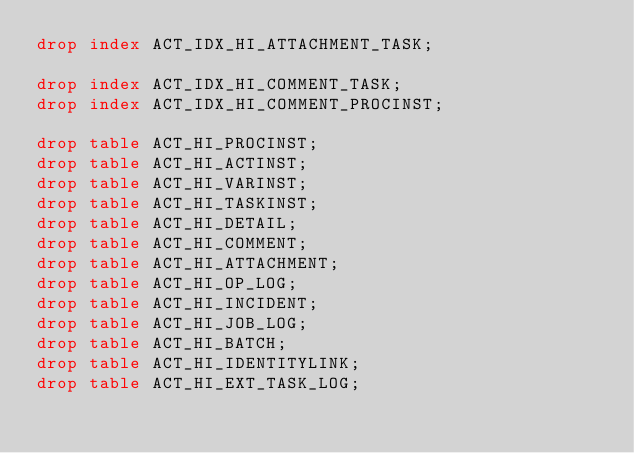<code> <loc_0><loc_0><loc_500><loc_500><_SQL_>drop index ACT_IDX_HI_ATTACHMENT_TASK;

drop index ACT_IDX_HI_COMMENT_TASK;
drop index ACT_IDX_HI_COMMENT_PROCINST;

drop table ACT_HI_PROCINST;
drop table ACT_HI_ACTINST;
drop table ACT_HI_VARINST;
drop table ACT_HI_TASKINST;
drop table ACT_HI_DETAIL;
drop table ACT_HI_COMMENT;
drop table ACT_HI_ATTACHMENT;
drop table ACT_HI_OP_LOG;
drop table ACT_HI_INCIDENT;
drop table ACT_HI_JOB_LOG;
drop table ACT_HI_BATCH;
drop table ACT_HI_IDENTITYLINK;
drop table ACT_HI_EXT_TASK_LOG;</code> 